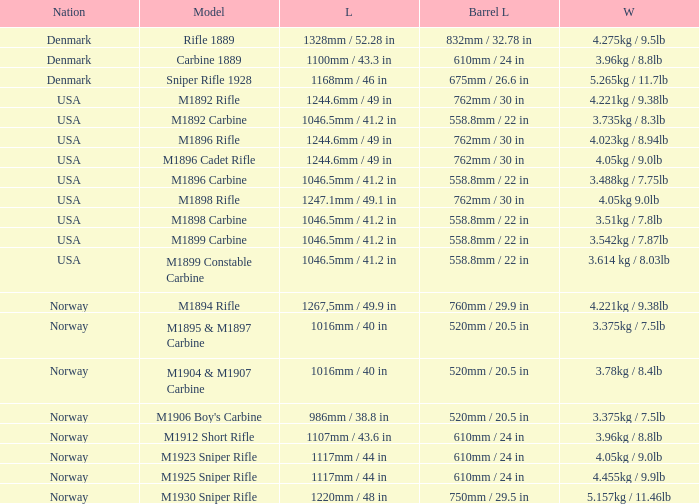Can you parse all the data within this table? {'header': ['Nation', 'Model', 'L', 'Barrel L', 'W'], 'rows': [['Denmark', 'Rifle 1889', '1328mm / 52.28 in', '832mm / 32.78 in', '4.275kg / 9.5lb'], ['Denmark', 'Carbine 1889', '1100mm / 43.3 in', '610mm / 24 in', '3.96kg / 8.8lb'], ['Denmark', 'Sniper Rifle 1928', '1168mm / 46 in', '675mm / 26.6 in', '5.265kg / 11.7lb'], ['USA', 'M1892 Rifle', '1244.6mm / 49 in', '762mm / 30 in', '4.221kg / 9.38lb'], ['USA', 'M1892 Carbine', '1046.5mm / 41.2 in', '558.8mm / 22 in', '3.735kg / 8.3lb'], ['USA', 'M1896 Rifle', '1244.6mm / 49 in', '762mm / 30 in', '4.023kg / 8.94lb'], ['USA', 'M1896 Cadet Rifle', '1244.6mm / 49 in', '762mm / 30 in', '4.05kg / 9.0lb'], ['USA', 'M1896 Carbine', '1046.5mm / 41.2 in', '558.8mm / 22 in', '3.488kg / 7.75lb'], ['USA', 'M1898 Rifle', '1247.1mm / 49.1 in', '762mm / 30 in', '4.05kg 9.0lb'], ['USA', 'M1898 Carbine', '1046.5mm / 41.2 in', '558.8mm / 22 in', '3.51kg / 7.8lb'], ['USA', 'M1899 Carbine', '1046.5mm / 41.2 in', '558.8mm / 22 in', '3.542kg / 7.87lb'], ['USA', 'M1899 Constable Carbine', '1046.5mm / 41.2 in', '558.8mm / 22 in', '3.614 kg / 8.03lb'], ['Norway', 'M1894 Rifle', '1267,5mm / 49.9 in', '760mm / 29.9 in', '4.221kg / 9.38lb'], ['Norway', 'M1895 & M1897 Carbine', '1016mm / 40 in', '520mm / 20.5 in', '3.375kg / 7.5lb'], ['Norway', 'M1904 & M1907 Carbine', '1016mm / 40 in', '520mm / 20.5 in', '3.78kg / 8.4lb'], ['Norway', "M1906 Boy's Carbine", '986mm / 38.8 in', '520mm / 20.5 in', '3.375kg / 7.5lb'], ['Norway', 'M1912 Short Rifle', '1107mm / 43.6 in', '610mm / 24 in', '3.96kg / 8.8lb'], ['Norway', 'M1923 Sniper Rifle', '1117mm / 44 in', '610mm / 24 in', '4.05kg / 9.0lb'], ['Norway', 'M1925 Sniper Rifle', '1117mm / 44 in', '610mm / 24 in', '4.455kg / 9.9lb'], ['Norway', 'M1930 Sniper Rifle', '1220mm / 48 in', '750mm / 29.5 in', '5.157kg / 11.46lb']]} What is Nation, when Model is M1895 & M1897 Carbine? Norway. 